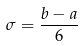<formula> <loc_0><loc_0><loc_500><loc_500>\sigma = \frac { b - a } { 6 }</formula> 